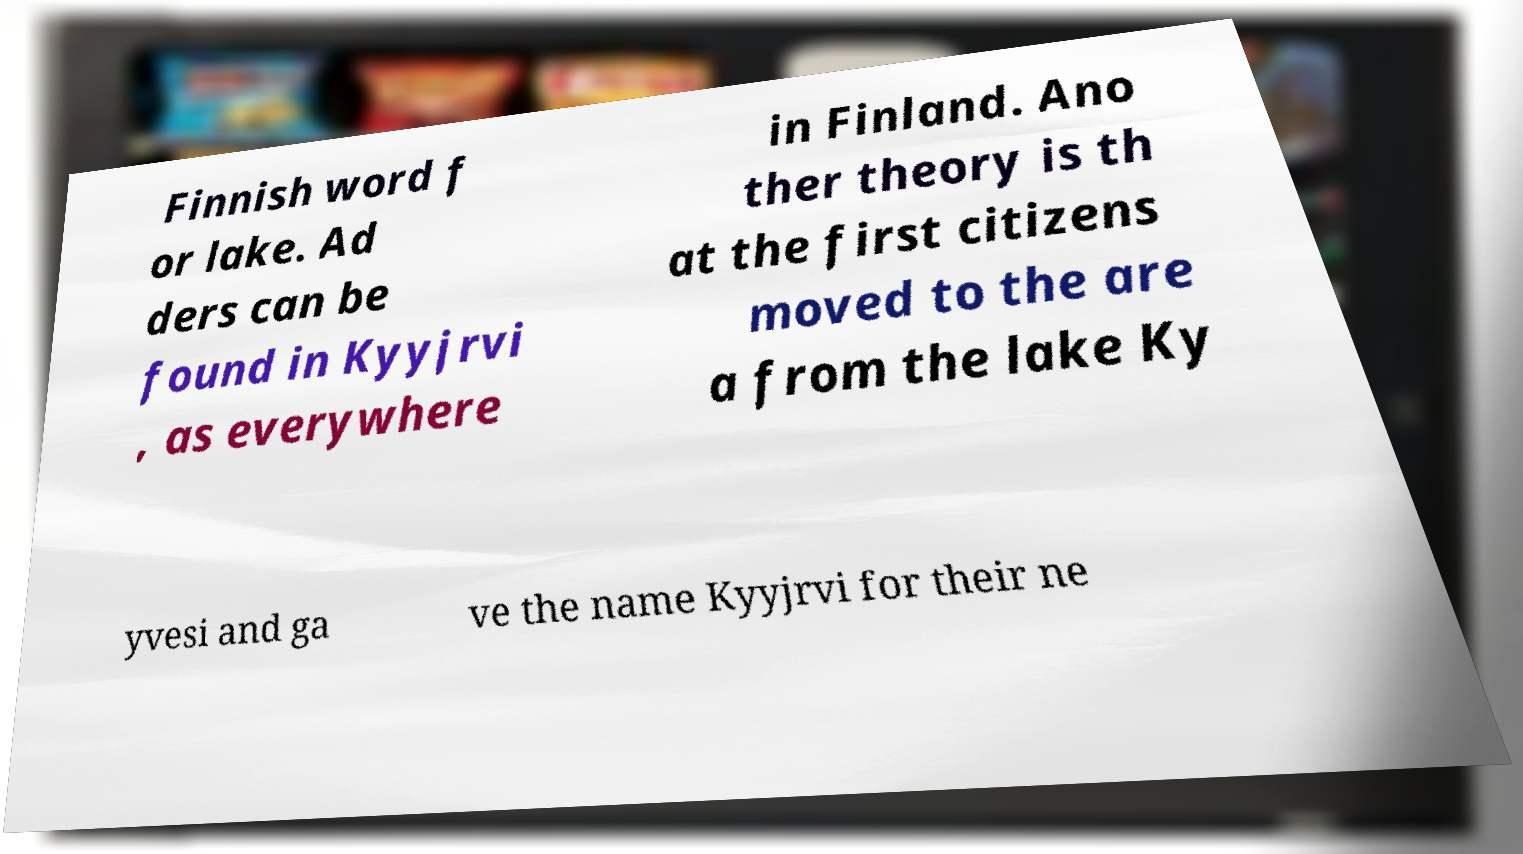Please read and relay the text visible in this image. What does it say? Finnish word f or lake. Ad ders can be found in Kyyjrvi , as everywhere in Finland. Ano ther theory is th at the first citizens moved to the are a from the lake Ky yvesi and ga ve the name Kyyjrvi for their ne 